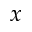Convert formula to latex. <formula><loc_0><loc_0><loc_500><loc_500>x</formula> 